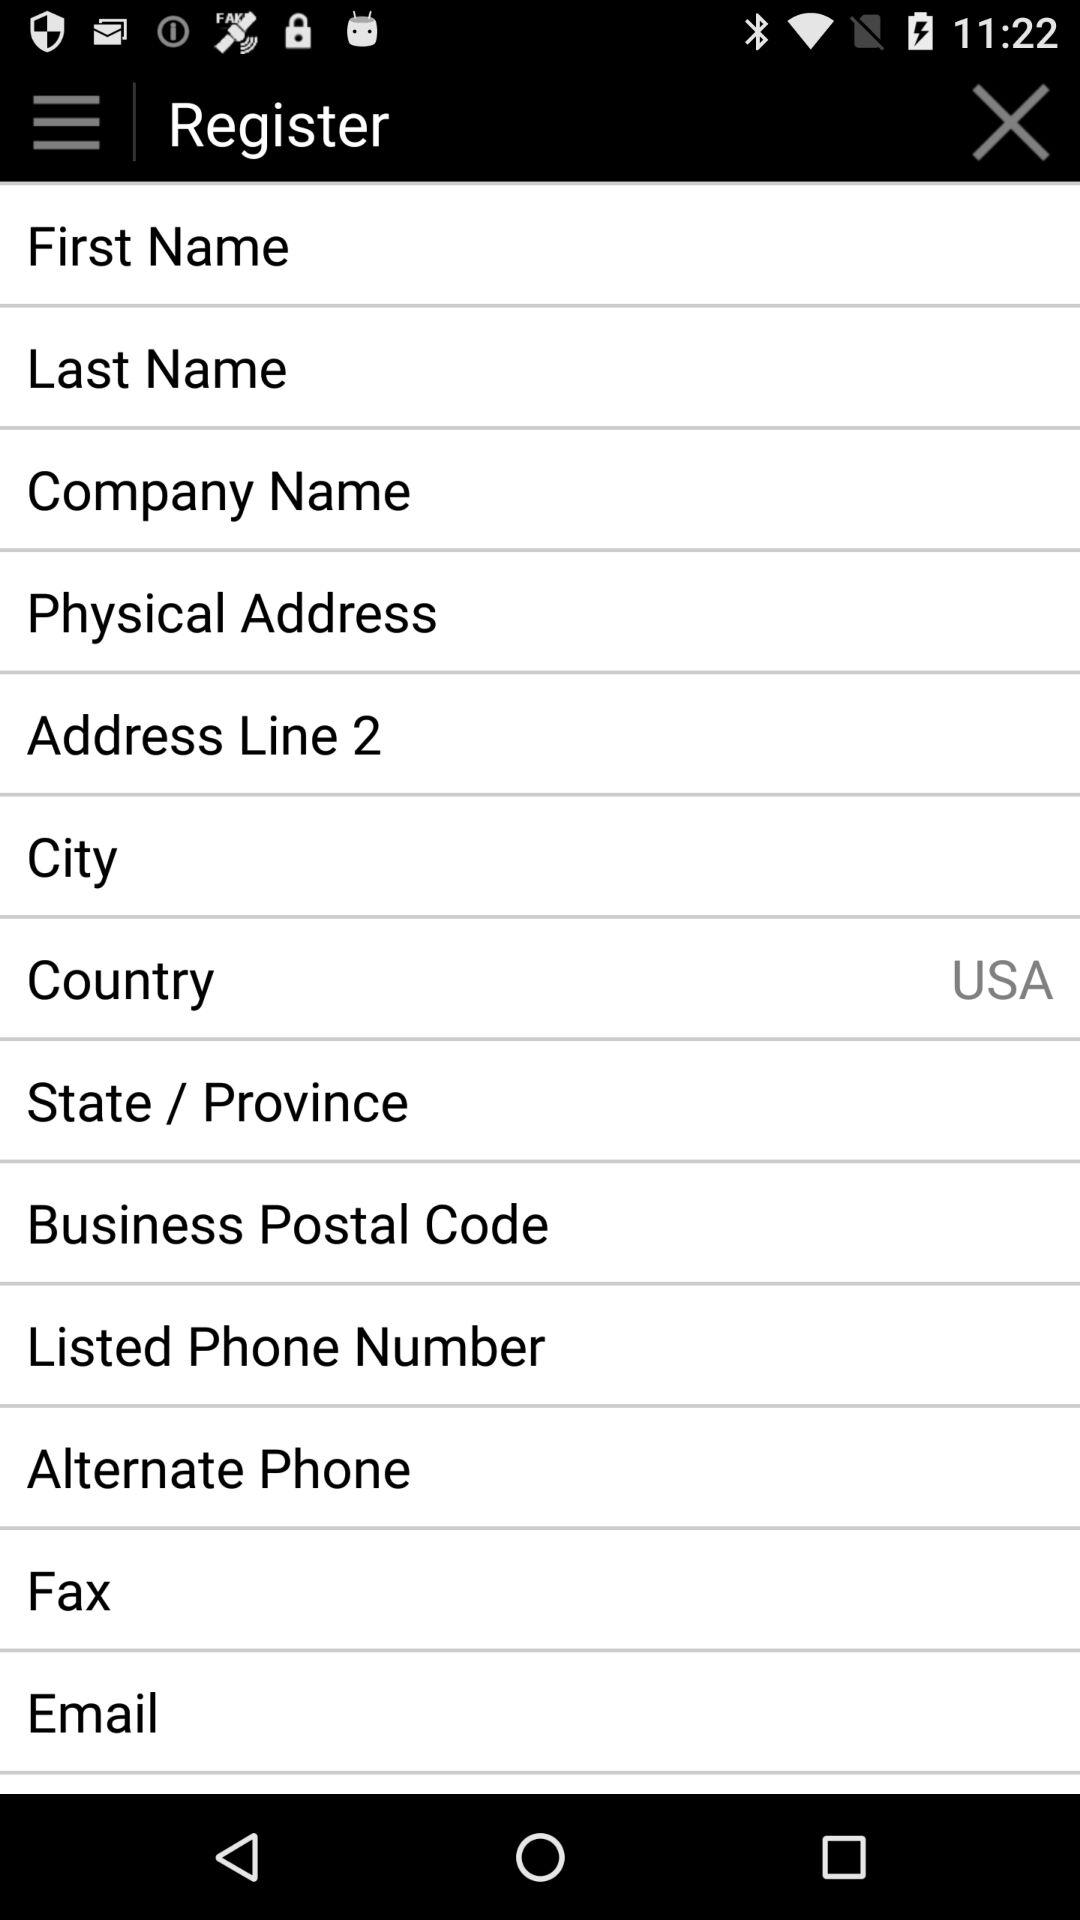What is the country name? The country name is the USA. 